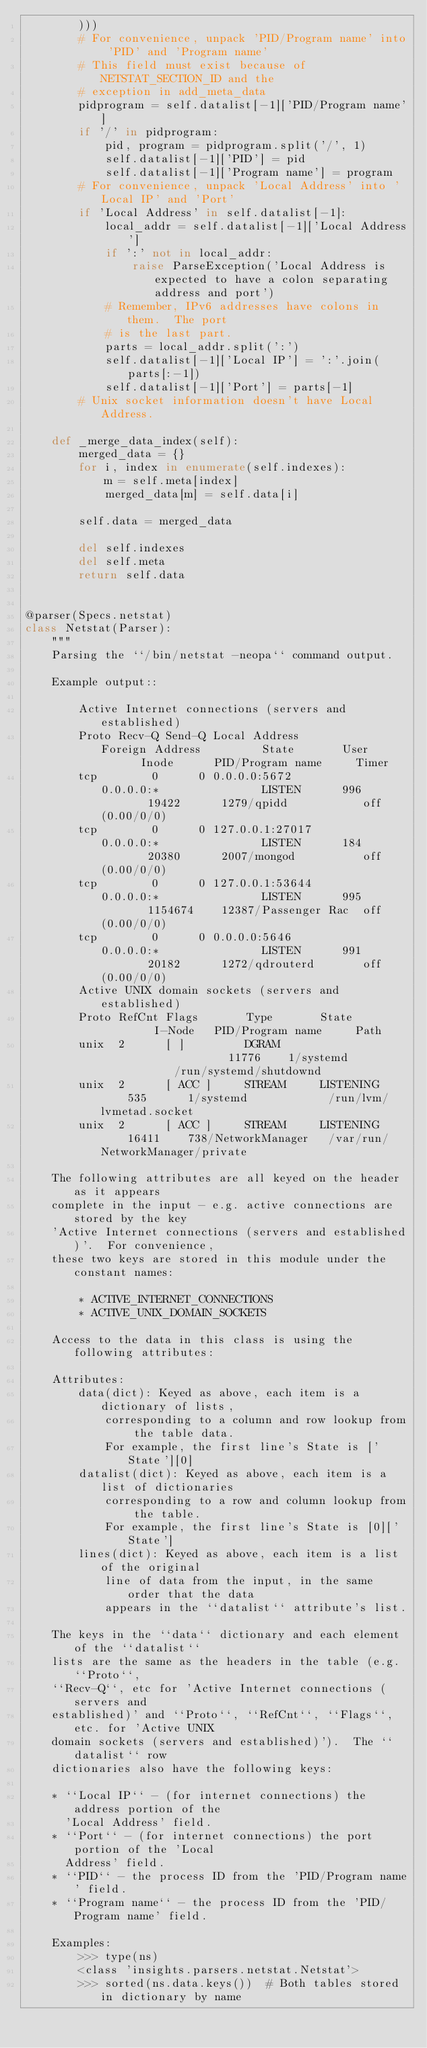Convert code to text. <code><loc_0><loc_0><loc_500><loc_500><_Python_>        )))
        # For convenience, unpack 'PID/Program name' into 'PID' and 'Program name'
        # This field must exist because of NETSTAT_SECTION_ID and the
        # exception in add_meta_data
        pidprogram = self.datalist[-1]['PID/Program name']
        if '/' in pidprogram:
            pid, program = pidprogram.split('/', 1)
            self.datalist[-1]['PID'] = pid
            self.datalist[-1]['Program name'] = program
        # For convenience, unpack 'Local Address' into 'Local IP' and 'Port'
        if 'Local Address' in self.datalist[-1]:
            local_addr = self.datalist[-1]['Local Address']
            if ':' not in local_addr:
                raise ParseException('Local Address is expected to have a colon separating address and port')
            # Remember, IPv6 addresses have colons in them.  The port
            # is the last part.
            parts = local_addr.split(':')
            self.datalist[-1]['Local IP'] = ':'.join(parts[:-1])
            self.datalist[-1]['Port'] = parts[-1]
        # Unix socket information doesn't have Local Address.

    def _merge_data_index(self):
        merged_data = {}
        for i, index in enumerate(self.indexes):
            m = self.meta[index]
            merged_data[m] = self.data[i]

        self.data = merged_data

        del self.indexes
        del self.meta
        return self.data


@parser(Specs.netstat)
class Netstat(Parser):
    """
    Parsing the ``/bin/netstat -neopa`` command output.

    Example output::

        Active Internet connections (servers and established)
        Proto Recv-Q Send-Q Local Address           Foreign Address         State       User       Inode      PID/Program name     Timer
        tcp        0      0 0.0.0.0:5672            0.0.0.0:*               LISTEN      996        19422      1279/qpidd           off (0.00/0/0)
        tcp        0      0 127.0.0.1:27017         0.0.0.0:*               LISTEN      184        20380      2007/mongod          off (0.00/0/0)
        tcp        0      0 127.0.0.1:53644         0.0.0.0:*               LISTEN      995        1154674    12387/Passenger Rac  off (0.00/0/0)
        tcp        0      0 0.0.0.0:5646            0.0.0.0:*               LISTEN      991        20182      1272/qdrouterd       off (0.00/0/0)
        Active UNIX domain sockets (servers and established)
        Proto RefCnt Flags       Type       State         I-Node   PID/Program name     Path
        unix  2      [ ]         DGRAM                    11776    1/systemd            /run/systemd/shutdownd
        unix  2      [ ACC ]     STREAM     LISTENING     535      1/systemd            /run/lvm/lvmetad.socket
        unix  2      [ ACC ]     STREAM     LISTENING     16411    738/NetworkManager   /var/run/NetworkManager/private

    The following attributes are all keyed on the header as it appears
    complete in the input - e.g. active connections are stored by the key
    'Active Internet connections (servers and established)'.  For convenience,
    these two keys are stored in this module under the constant names:

        * ACTIVE_INTERNET_CONNECTIONS
        * ACTIVE_UNIX_DOMAIN_SOCKETS

    Access to the data in this class is using the following attributes:

    Attributes:
        data(dict): Keyed as above, each item is a dictionary of lists,
            corresponding to a column and row lookup from the table data.
            For example, the first line's State is ['State'][0]
        datalist(dict): Keyed as above, each item is a list of dictionaries
            corresponding to a row and column lookup from the table.
            For example, the first line's State is [0]['State']
        lines(dict): Keyed as above, each item is a list of the original
            line of data from the input, in the same order that the data
            appears in the ``datalist`` attribute's list.

    The keys in the ``data`` dictionary and each element of the ``datalist``
    lists are the same as the headers in the table (e.g. ``Proto``,
    ``Recv-Q``, etc for 'Active Internet connections (servers and
    established)' and ``Proto``, ``RefCnt``, ``Flags``, etc. for 'Active UNIX
    domain sockets (servers and established)').  The ``datalist`` row
    dictionaries also have the following keys:

    * ``Local IP`` - (for internet connections) the address portion of the
      'Local Address' field.
    * ``Port`` - (for internet connections) the port portion of the 'Local
      Address' field.
    * ``PID`` - the process ID from the 'PID/Program name' field.
    * ``Program name`` - the process ID from the 'PID/Program name' field.

    Examples:
        >>> type(ns)
        <class 'insights.parsers.netstat.Netstat'>
        >>> sorted(ns.data.keys())  # Both tables stored in dictionary by name</code> 